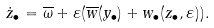<formula> <loc_0><loc_0><loc_500><loc_500>\dot { z } _ { \bullet } = \overline { \omega } + \varepsilon ( \overline { w } ( y _ { \bullet } ) + w _ { \bullet } ( z _ { \bullet } , \varepsilon ) ) .</formula> 